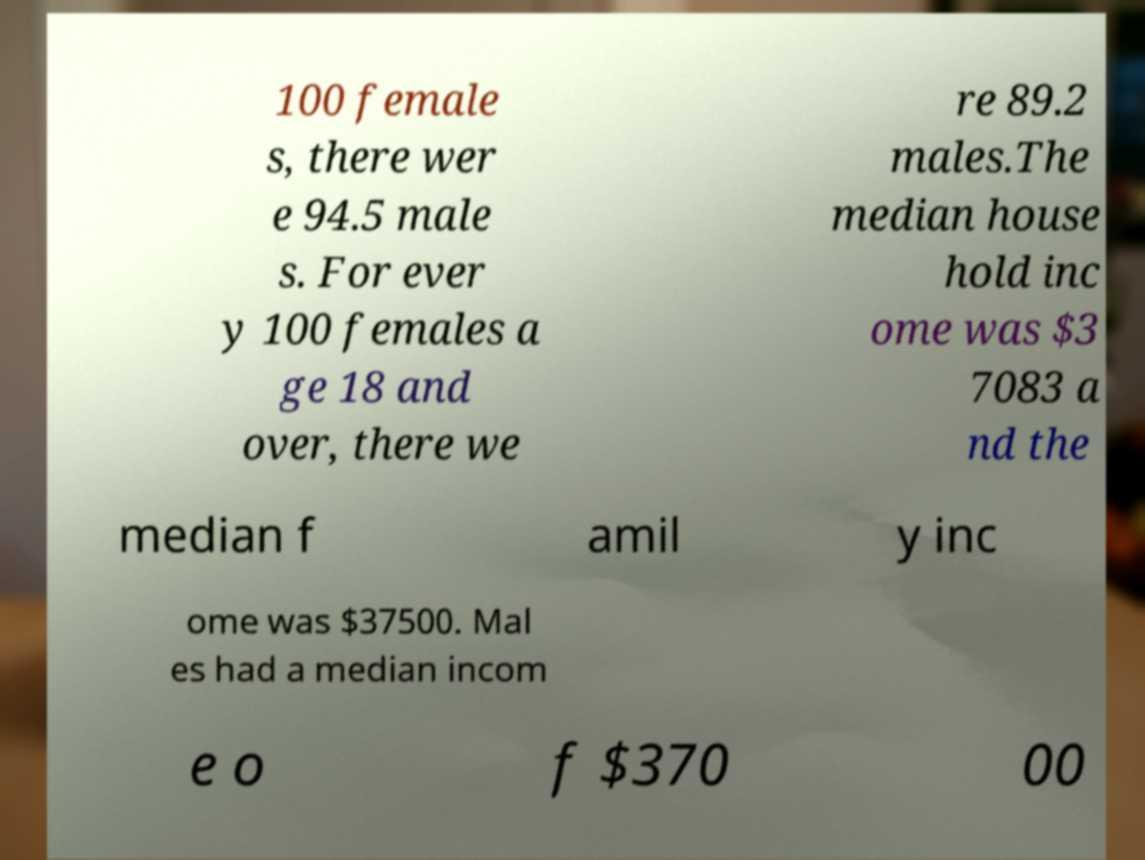Can you read and provide the text displayed in the image?This photo seems to have some interesting text. Can you extract and type it out for me? 100 female s, there wer e 94.5 male s. For ever y 100 females a ge 18 and over, there we re 89.2 males.The median house hold inc ome was $3 7083 a nd the median f amil y inc ome was $37500. Mal es had a median incom e o f $370 00 